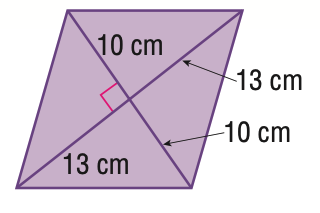Answer the mathemtical geometry problem and directly provide the correct option letter.
Question: Find the area of the quadrilateral.
Choices: A: 130 B: 230 C: 260 D: 520 C 